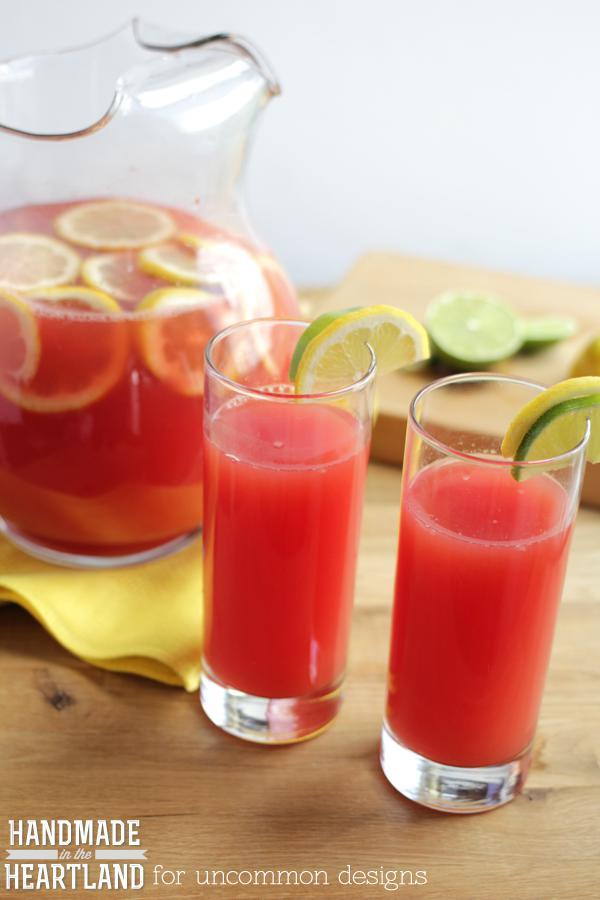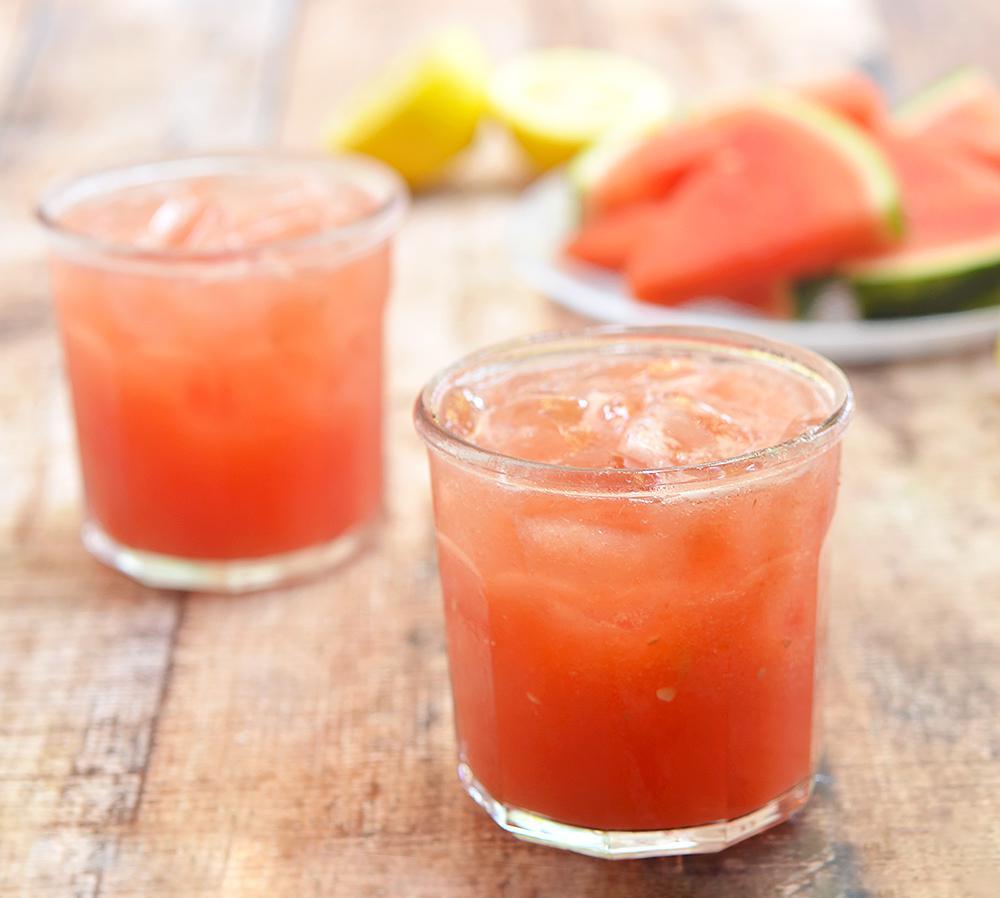The first image is the image on the left, the second image is the image on the right. Given the left and right images, does the statement "Both images show a red drink in a clear glass with a lemon slice on the edge of the glass" hold true? Answer yes or no. No. The first image is the image on the left, the second image is the image on the right. Considering the images on both sides, is "At least some of the beverages are served in jars and have straws inserted." valid? Answer yes or no. No. 